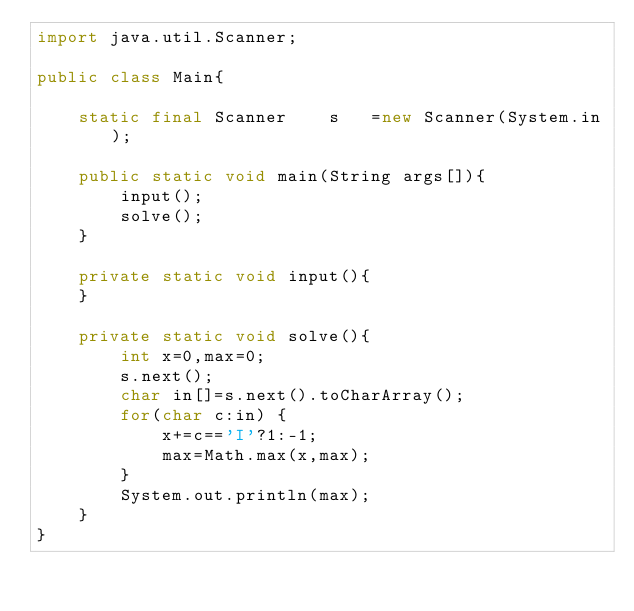<code> <loc_0><loc_0><loc_500><loc_500><_Java_>import java.util.Scanner;

public class Main{

	static final Scanner	s	=new Scanner(System.in);

	public static void main(String args[]){
		input();
		solve();
	}

	private static void input(){
	}

	private static void solve(){
		int x=0,max=0;
		s.next();
		char in[]=s.next().toCharArray();
		for(char c:in) {
			x+=c=='I'?1:-1;
			max=Math.max(x,max);
		}
		System.out.println(max);
	}
}
</code> 